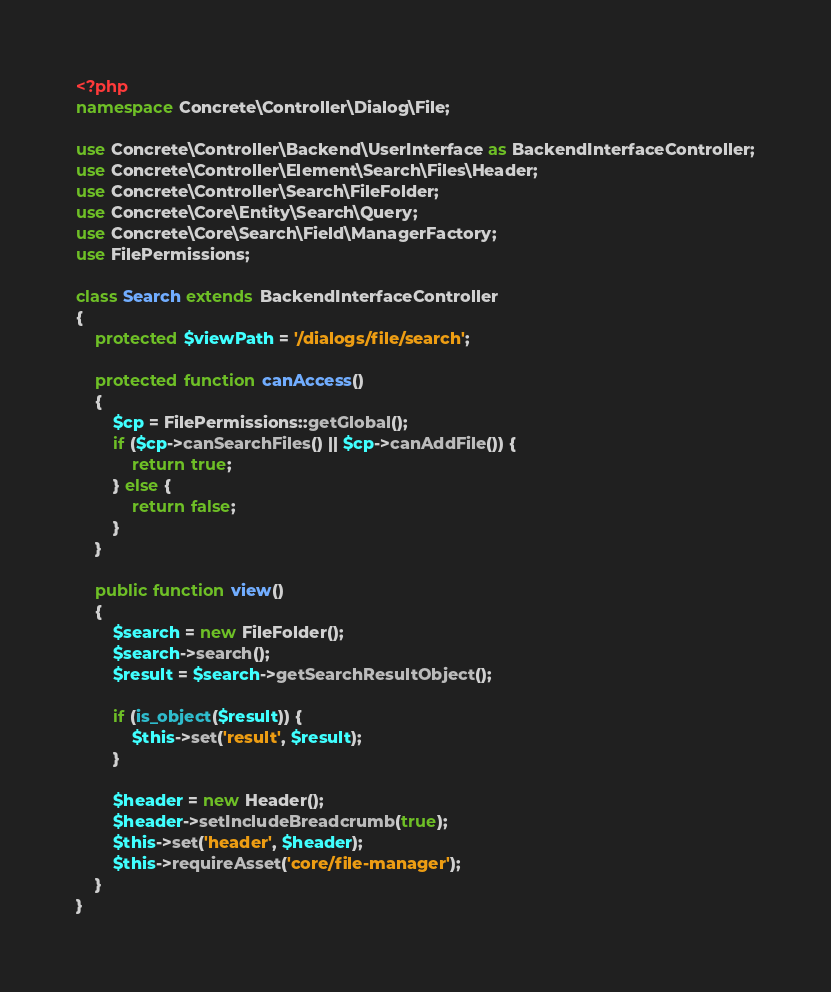Convert code to text. <code><loc_0><loc_0><loc_500><loc_500><_PHP_><?php
namespace Concrete\Controller\Dialog\File;

use Concrete\Controller\Backend\UserInterface as BackendInterfaceController;
use Concrete\Controller\Element\Search\Files\Header;
use Concrete\Controller\Search\FileFolder;
use Concrete\Core\Entity\Search\Query;
use Concrete\Core\Search\Field\ManagerFactory;
use FilePermissions;

class Search extends BackendInterfaceController
{
    protected $viewPath = '/dialogs/file/search';

    protected function canAccess()
    {
        $cp = FilePermissions::getGlobal();
        if ($cp->canSearchFiles() || $cp->canAddFile()) {
            return true;
        } else {
            return false;
        }
    }

    public function view()
    {
        $search = new FileFolder();
        $search->search();
        $result = $search->getSearchResultObject();

        if (is_object($result)) {
            $this->set('result', $result);
        }

        $header = new Header();
        $header->setIncludeBreadcrumb(true);
        $this->set('header', $header);
        $this->requireAsset('core/file-manager');
    }
}
</code> 